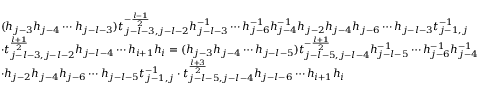Convert formula to latex. <formula><loc_0><loc_0><loc_500><loc_500>\begin{array} { r l } & { ( h _ { j - 3 } h _ { j - 4 } \cdots h _ { j - l - 3 } ) t _ { j - l - 3 , j - l - 2 } ^ { - \frac { l - 1 } { 2 } } h _ { j - l - 3 } ^ { - 1 } \cdots h _ { j - 6 } ^ { - 1 } h _ { j - 4 } ^ { - 1 } h _ { j - 2 } h _ { j - 4 } h _ { j - 6 } \cdots h _ { j - l - 3 } t _ { j - 1 , j } ^ { - 1 } } \\ & { \cdot t _ { j - l - 3 , j - l - 2 } ^ { \frac { l + 1 } { 2 } } h _ { j - l - 4 } \cdots h _ { i + 1 } h _ { i } = ( h _ { j - 3 } h _ { j - 4 } \cdots h _ { j - l - 5 } ) t _ { j - l - 5 , j - l - 4 } ^ { - \frac { l + 1 } { 2 } } h _ { j - l - 5 } ^ { - 1 } \cdots h _ { j - 6 } ^ { - 1 } h _ { j - 4 } ^ { - 1 } } \\ & { \cdot h _ { j - 2 } h _ { j - 4 } h _ { j - 6 } \cdots h _ { j - l - 5 } t _ { j - 1 , j } ^ { - 1 } \cdot t _ { j - l - 5 , j - l - 4 } ^ { \frac { l + 3 } { 2 } } h _ { j - l - 6 } \cdots h _ { i + 1 } h _ { i } } \end{array}</formula> 